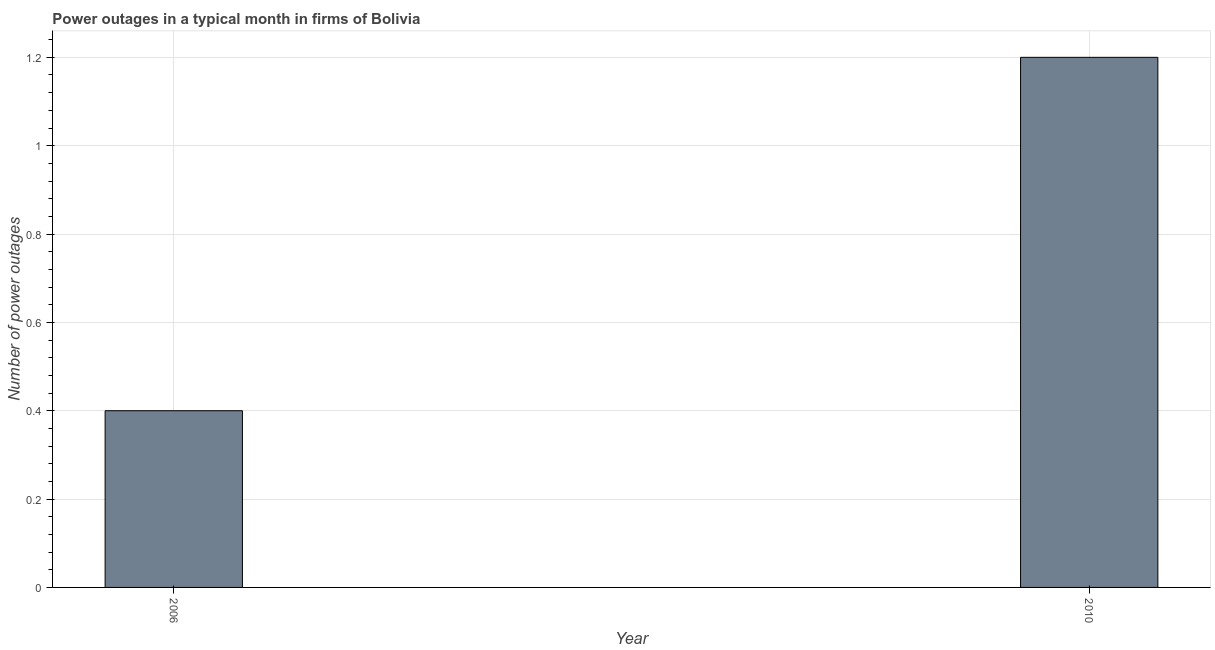Does the graph contain any zero values?
Offer a very short reply. No. What is the title of the graph?
Keep it short and to the point. Power outages in a typical month in firms of Bolivia. What is the label or title of the X-axis?
Your answer should be compact. Year. What is the label or title of the Y-axis?
Keep it short and to the point. Number of power outages. What is the number of power outages in 2006?
Your answer should be compact. 0.4. In which year was the number of power outages maximum?
Keep it short and to the point. 2010. In which year was the number of power outages minimum?
Give a very brief answer. 2006. What is the sum of the number of power outages?
Provide a short and direct response. 1.6. What is the median number of power outages?
Provide a short and direct response. 0.8. Do a majority of the years between 2006 and 2010 (inclusive) have number of power outages greater than 1.08 ?
Provide a succinct answer. No. What is the ratio of the number of power outages in 2006 to that in 2010?
Your answer should be very brief. 0.33. Is the number of power outages in 2006 less than that in 2010?
Keep it short and to the point. Yes. In how many years, is the number of power outages greater than the average number of power outages taken over all years?
Provide a succinct answer. 1. How many years are there in the graph?
Ensure brevity in your answer.  2. What is the difference between two consecutive major ticks on the Y-axis?
Provide a succinct answer. 0.2. What is the Number of power outages in 2010?
Ensure brevity in your answer.  1.2. What is the difference between the Number of power outages in 2006 and 2010?
Your answer should be very brief. -0.8. What is the ratio of the Number of power outages in 2006 to that in 2010?
Offer a very short reply. 0.33. 